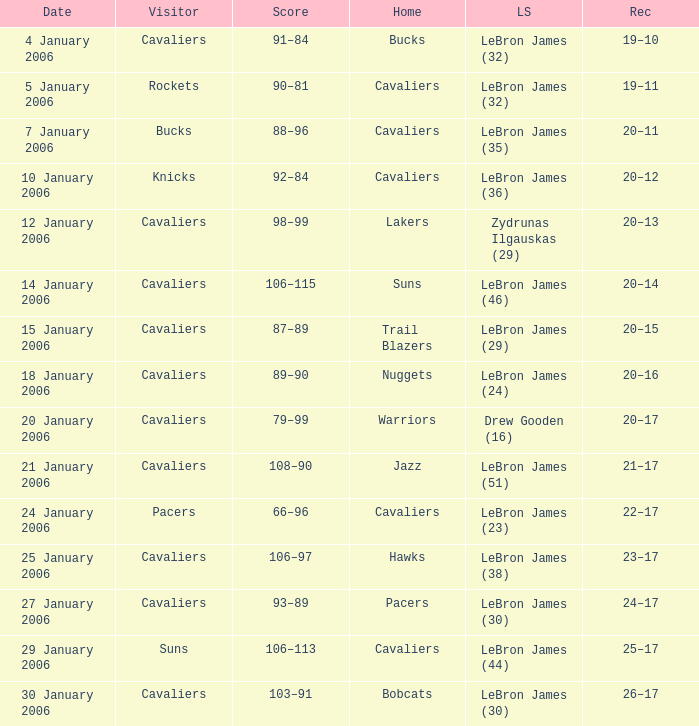Who was the leading score in the game at the Warriors? Drew Gooden (16). 